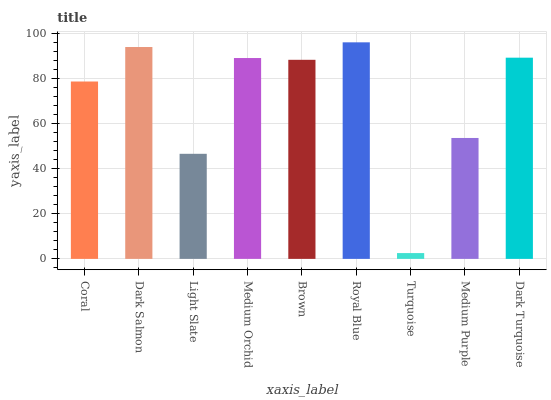Is Dark Salmon the minimum?
Answer yes or no. No. Is Dark Salmon the maximum?
Answer yes or no. No. Is Dark Salmon greater than Coral?
Answer yes or no. Yes. Is Coral less than Dark Salmon?
Answer yes or no. Yes. Is Coral greater than Dark Salmon?
Answer yes or no. No. Is Dark Salmon less than Coral?
Answer yes or no. No. Is Brown the high median?
Answer yes or no. Yes. Is Brown the low median?
Answer yes or no. Yes. Is Turquoise the high median?
Answer yes or no. No. Is Royal Blue the low median?
Answer yes or no. No. 